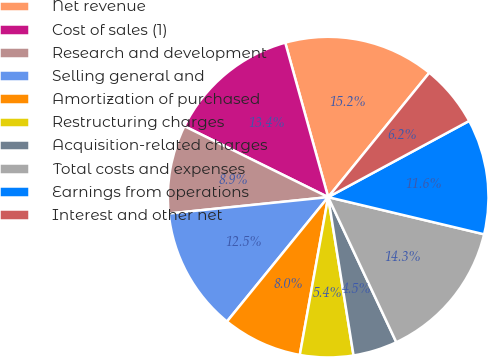<chart> <loc_0><loc_0><loc_500><loc_500><pie_chart><fcel>Net revenue<fcel>Cost of sales (1)<fcel>Research and development<fcel>Selling general and<fcel>Amortization of purchased<fcel>Restructuring charges<fcel>Acquisition-related charges<fcel>Total costs and expenses<fcel>Earnings from operations<fcel>Interest and other net<nl><fcel>15.18%<fcel>13.39%<fcel>8.93%<fcel>12.5%<fcel>8.04%<fcel>5.36%<fcel>4.46%<fcel>14.29%<fcel>11.61%<fcel>6.25%<nl></chart> 